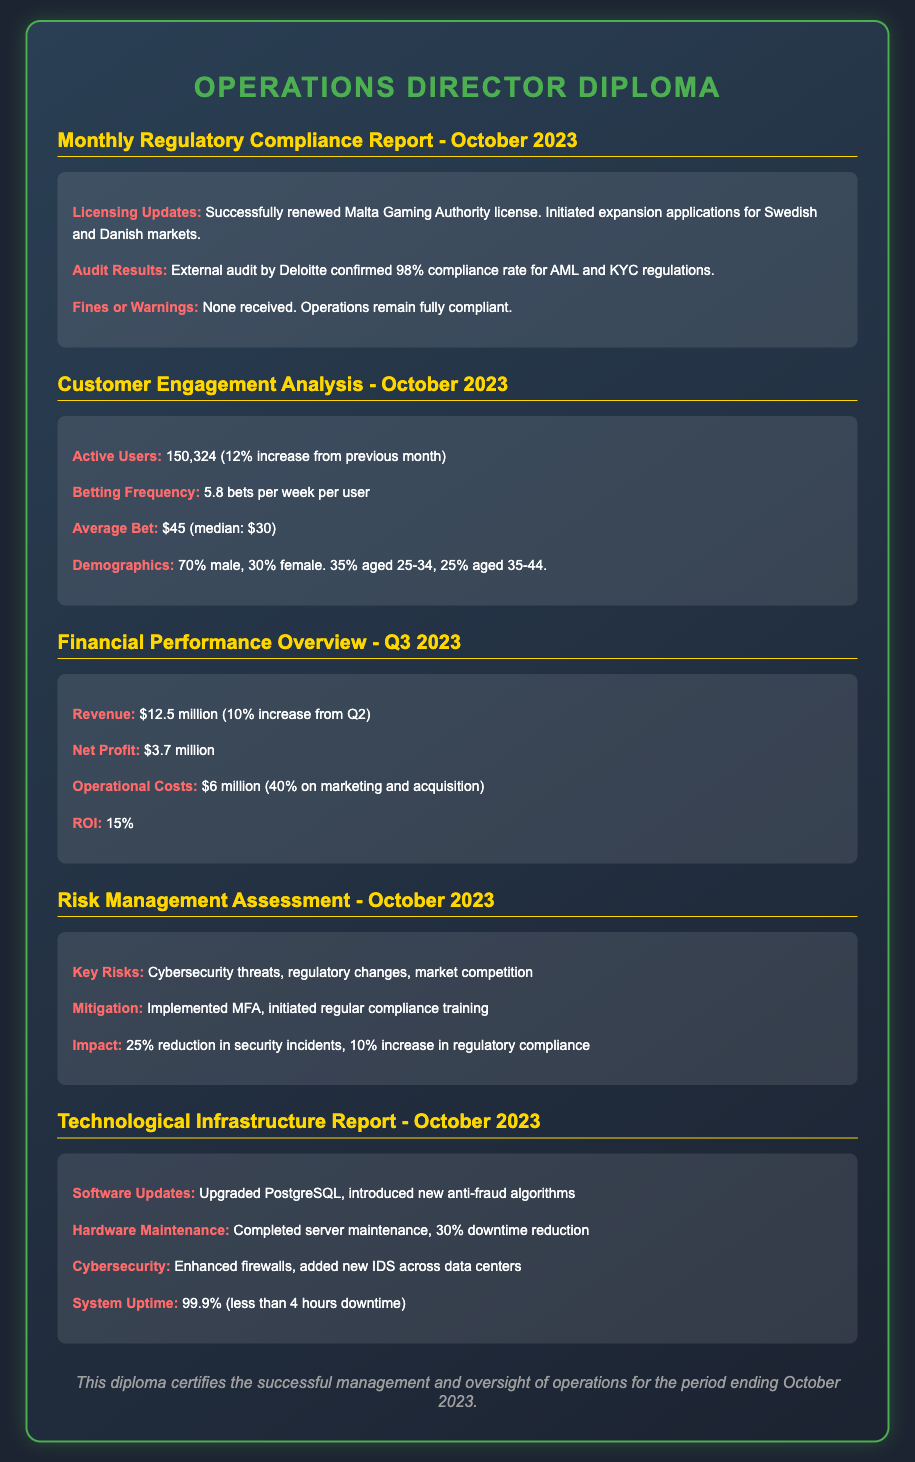What is the licensing update for October 2023? The licensing update mentions the successful renewal of the Malta Gaming Authority license and the initiation of expansion applications for Swedish and Danish markets.
Answer: Successfully renewed Malta Gaming Authority license What is the percentage increase in active users from the previous month? The document states there were 150,324 active users, which is a 12% increase from the previous month.
Answer: 12% What was the net profit for Q3 2023? The net profit listed in the Financial Performance Overview for Q3 2023 is specified directly in the document.
Answer: $3.7 million What were the key risks identified in October 2023? The key risks mentioned in the Risk Management Assessment are cybersecurity threats, regulatory changes, and market competition.
Answer: Cybersecurity threats, regulatory changes, market competition What was the system uptime percentage for October 2023? The Technological Infrastructure Report specifies the system uptime as a percentage, providing a clear numerical value.
Answer: 99.9% 